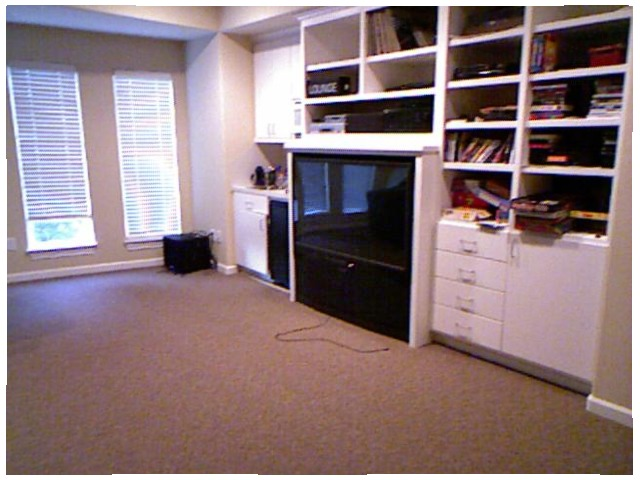<image>
Is there a cord in front of the television? Yes. The cord is positioned in front of the television, appearing closer to the camera viewpoint. Is there a book on the shelf? Yes. Looking at the image, I can see the book is positioned on top of the shelf, with the shelf providing support. Is the television next to the books? Yes. The television is positioned adjacent to the books, located nearby in the same general area. Is the book in the shelf? Yes. The book is contained within or inside the shelf, showing a containment relationship. 